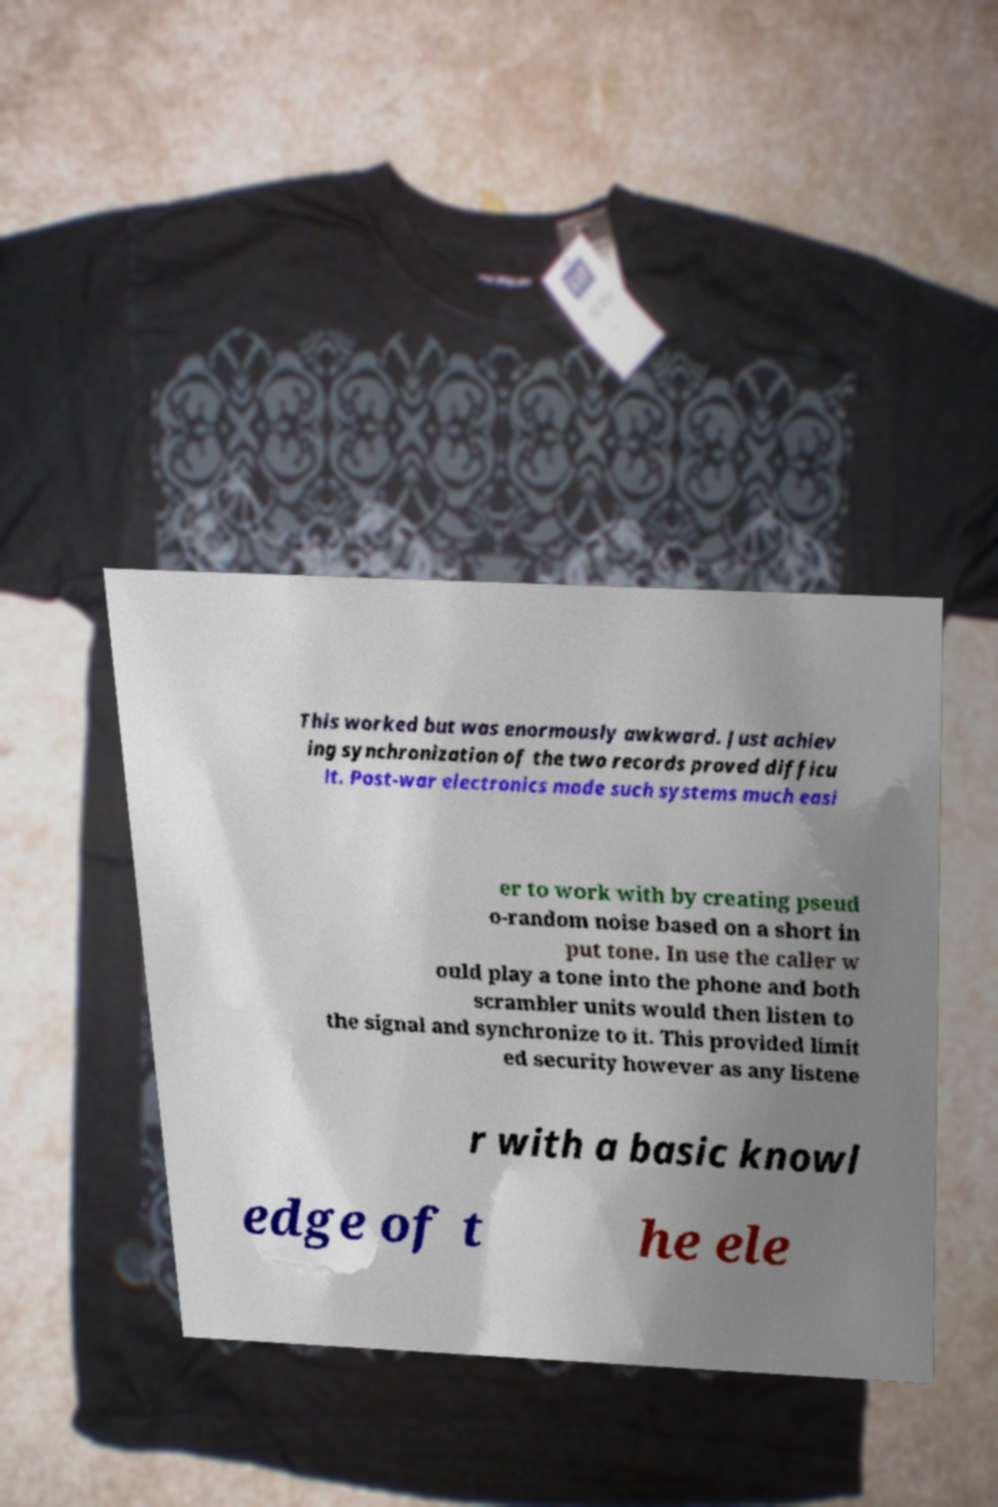Can you accurately transcribe the text from the provided image for me? This worked but was enormously awkward. Just achiev ing synchronization of the two records proved difficu lt. Post-war electronics made such systems much easi er to work with by creating pseud o-random noise based on a short in put tone. In use the caller w ould play a tone into the phone and both scrambler units would then listen to the signal and synchronize to it. This provided limit ed security however as any listene r with a basic knowl edge of t he ele 